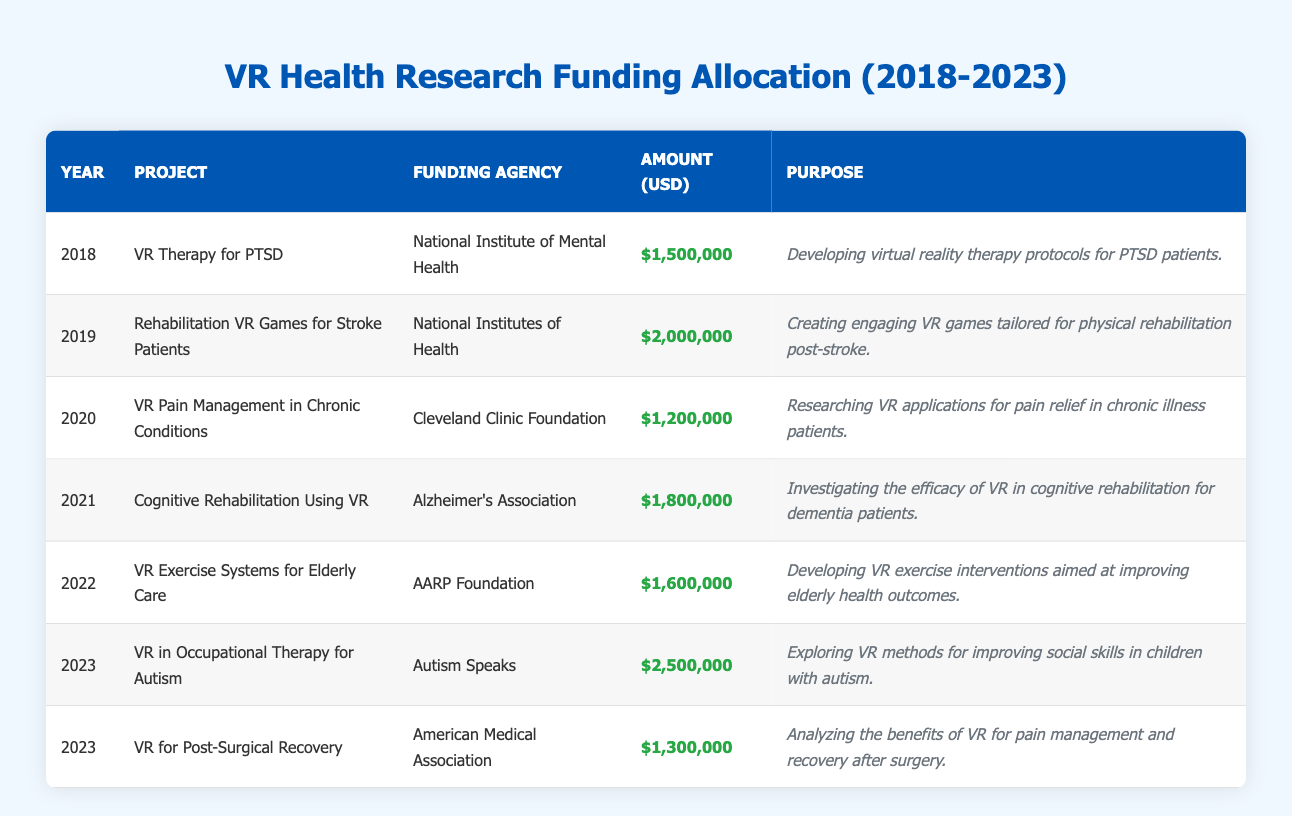What was the total funding allocated for VR health projects in 2022? The amount allocated for the project "VR Exercise Systems for Elderly Care" in 2022 was $1,600,000. This is the only project listed for that year, so the total is also $1,600,000.
Answer: $1,600,000 Which project received the highest funding amount? The project "VR in Occupational Therapy for Autism" in 2023 received $2,500,000, which is higher than all other individual project funding amounts listed in the table.
Answer: $2,500,000 How much funding was allocated for VR health projects in 2021 compared to 2019? The funding amount for 2021 (Cognitive Rehabilitation Using VR) was $1,800,000 and for 2019 (Rehabilitation VR Games for Stroke Patients) it was $2,000,000. To compare, we find that $2,000,000 (2019) - $1,800,000 (2021) = $200,000, meaning 2019 received $200,000 more in funding than 2021.
Answer: $200,000 How many projects received funding of $1,500,000 or less? Only the project "VR Pain Management in Chronic Conditions" with $1,200,000 falls under this criteria. Additionally, the project "VR Therapy for PTSD" received exactly $1,500,000, so that counts too. Therefore, there are 2 projects within this funding range.
Answer: 2 Was there an increase or decrease in funding from 2020 to 2021? In 2020, the funding was $1,200,000 for "VR Pain Management in Chronic Conditions" and in 2021, it was $1,800,000 for "Cognitive Rehabilitation Using VR." By comparing the two amounts, we find $1,800,000 (2021) - $1,200,000 (2020) = $600,000, indicating a clear increase in funding.
Answer: Increase What is the average funding amount for VR health projects from 2018 to 2023? To find the average, first, we sum all the funding amounts ($1,500,000 + $2,000,000 + $1,200,000 + $1,800,000 + $1,600,000 + $2,500,000 + $1,300,000 = $11,900,000), and then divide by the number of projects (7). Therefore, the average is $11,900,000 / 7 ≈ $1,700,000.
Answer: $1,700,000 Which year had the highest number of projects funded? In 2023, there were 2 projects listed: "VR in Occupational Therapy for Autism" and "VR for Post-Surgical Recovery." No other year had more than 1 project funded, making 2023 the year with the highest number of projects funded.
Answer: 2023 Did any funding agency fund more than one project? Yes, the funding agency "Autism Speaks" funded one project in 2023, and more importantly, there are no overlapping agencies funding multiple projects in the displayed data, so the answer is no, each agency funded only one project.
Answer: No What was the total funding allocated in 2023? The total funding for 2023 includes the amounts for the two projects: $2,500,000 (VR in Occupational Therapy for Autism) and $1,300,000 (VR for Post-Surgical Recovery). Therefore, the total is $2,500,000 + $1,300,000 = $3,800,000.
Answer: $3,800,000 